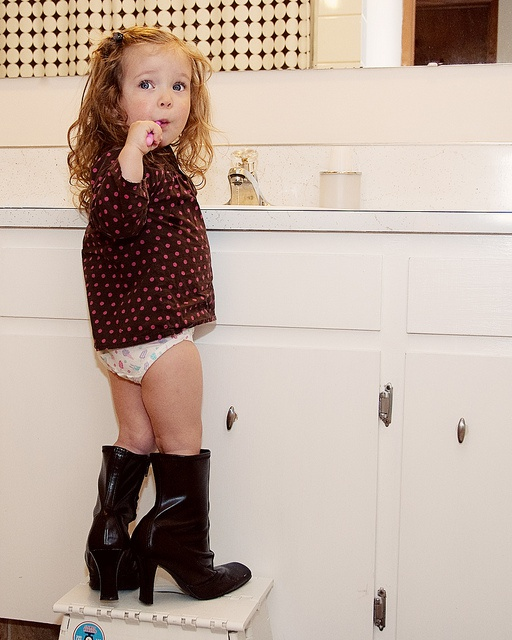Describe the objects in this image and their specific colors. I can see people in tan, black, maroon, and brown tones, sink in tan, lightgray, and gray tones, cup in tan and lightgray tones, and toothbrush in tan, lightpink, violet, and brown tones in this image. 